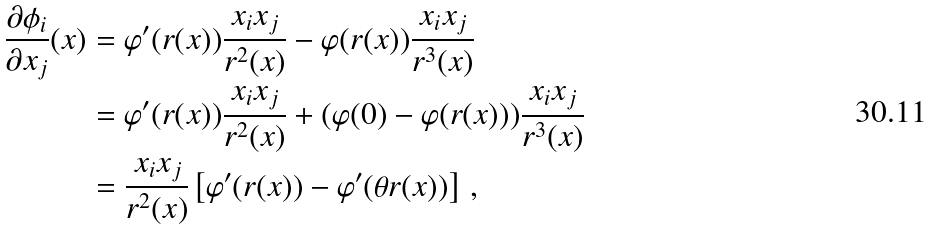<formula> <loc_0><loc_0><loc_500><loc_500>\frac { \partial \phi _ { i } } { \partial x _ { j } } ( x ) & = \varphi ^ { \prime } ( r ( x ) ) \frac { x _ { i } x _ { j } } { r ^ { 2 } ( x ) } - \varphi ( r ( x ) ) \frac { x _ { i } x _ { j } } { r ^ { 3 } ( x ) } \\ & = \varphi ^ { \prime } ( r ( x ) ) \frac { x _ { i } x _ { j } } { r ^ { 2 } ( x ) } + ( \varphi ( 0 ) - \varphi ( r ( x ) ) ) \frac { x _ { i } x _ { j } } { r ^ { 3 } ( x ) } \\ & = \frac { x _ { i } x _ { j } } { r ^ { 2 } ( x ) } \left [ \varphi ^ { \prime } ( r ( x ) ) - \varphi ^ { \prime } ( \theta r ( x ) ) \right ] \, ,</formula> 